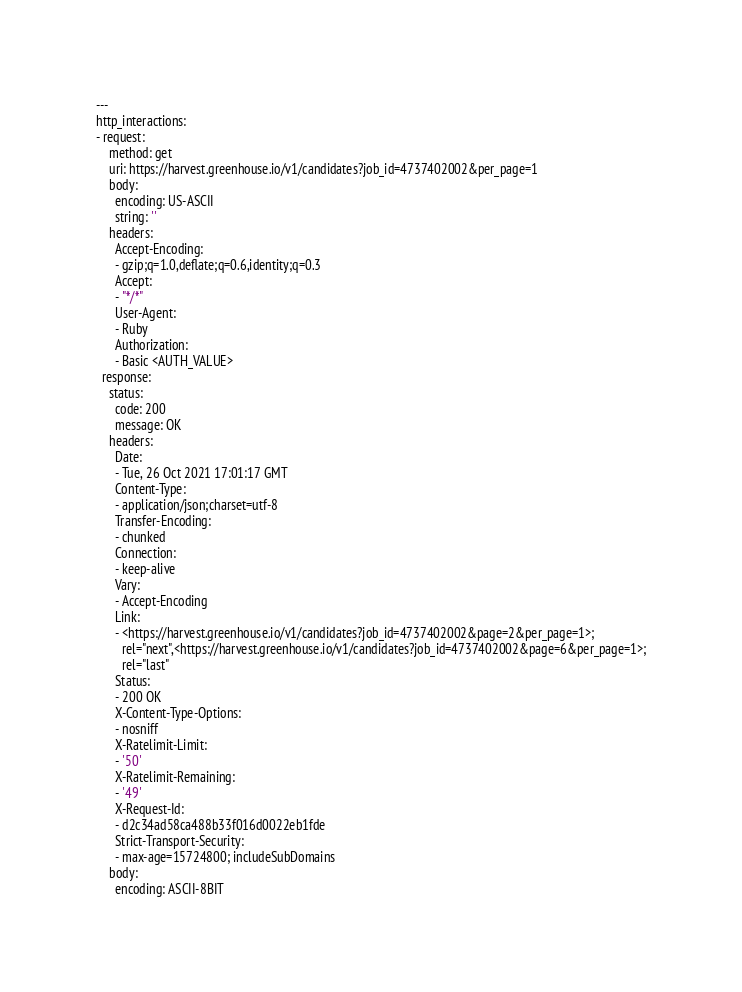<code> <loc_0><loc_0><loc_500><loc_500><_YAML_>---
http_interactions:
- request:
    method: get
    uri: https://harvest.greenhouse.io/v1/candidates?job_id=4737402002&per_page=1
    body:
      encoding: US-ASCII
      string: ''
    headers:
      Accept-Encoding:
      - gzip;q=1.0,deflate;q=0.6,identity;q=0.3
      Accept:
      - "*/*"
      User-Agent:
      - Ruby
      Authorization:
      - Basic <AUTH_VALUE>
  response:
    status:
      code: 200
      message: OK
    headers:
      Date:
      - Tue, 26 Oct 2021 17:01:17 GMT
      Content-Type:
      - application/json;charset=utf-8
      Transfer-Encoding:
      - chunked
      Connection:
      - keep-alive
      Vary:
      - Accept-Encoding
      Link:
      - <https://harvest.greenhouse.io/v1/candidates?job_id=4737402002&page=2&per_page=1>;
        rel="next",<https://harvest.greenhouse.io/v1/candidates?job_id=4737402002&page=6&per_page=1>;
        rel="last"
      Status:
      - 200 OK
      X-Content-Type-Options:
      - nosniff
      X-Ratelimit-Limit:
      - '50'
      X-Ratelimit-Remaining:
      - '49'
      X-Request-Id:
      - d2c34ad58ca488b33f016d0022eb1fde
      Strict-Transport-Security:
      - max-age=15724800; includeSubDomains
    body:
      encoding: ASCII-8BIT</code> 